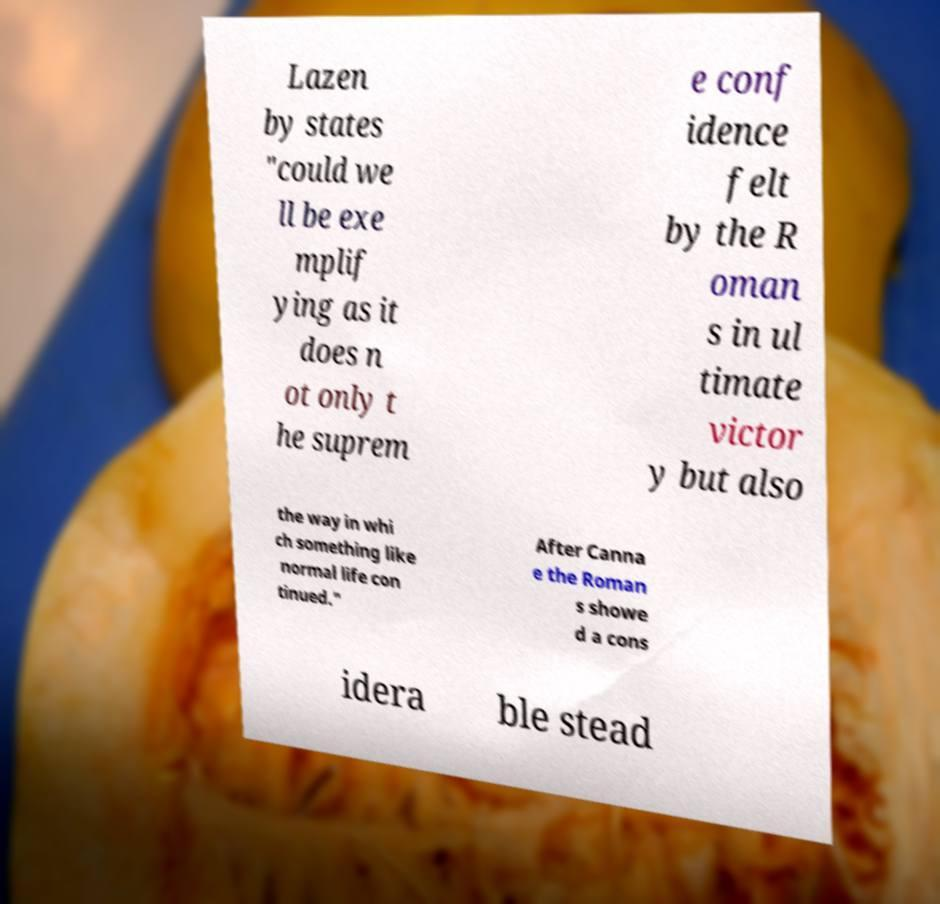Could you assist in decoding the text presented in this image and type it out clearly? Lazen by states "could we ll be exe mplif ying as it does n ot only t he suprem e conf idence felt by the R oman s in ul timate victor y but also the way in whi ch something like normal life con tinued." After Canna e the Roman s showe d a cons idera ble stead 